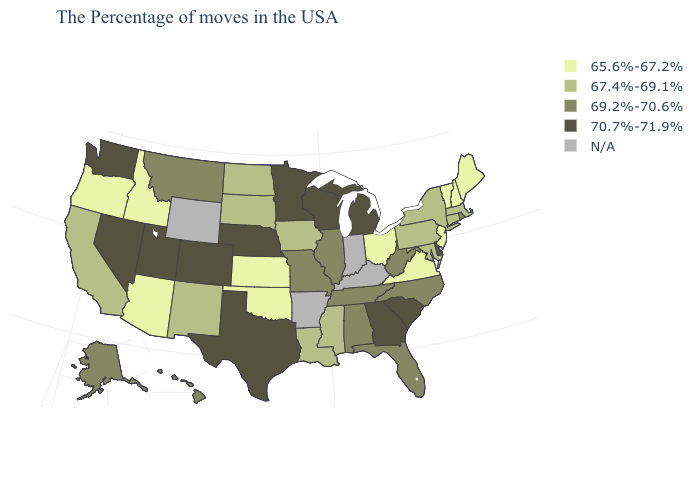What is the value of Arizona?
Short answer required. 65.6%-67.2%. What is the value of Kentucky?
Quick response, please. N/A. What is the lowest value in the MidWest?
Give a very brief answer. 65.6%-67.2%. Does Missouri have the lowest value in the MidWest?
Answer briefly. No. What is the value of Idaho?
Answer briefly. 65.6%-67.2%. What is the value of Utah?
Keep it brief. 70.7%-71.9%. Which states hav the highest value in the MidWest?
Keep it brief. Michigan, Wisconsin, Minnesota, Nebraska. What is the value of Nebraska?
Quick response, please. 70.7%-71.9%. Name the states that have a value in the range 67.4%-69.1%?
Concise answer only. Massachusetts, Connecticut, New York, Maryland, Pennsylvania, Mississippi, Louisiana, Iowa, South Dakota, North Dakota, New Mexico, California. Name the states that have a value in the range 69.2%-70.6%?
Give a very brief answer. Rhode Island, North Carolina, West Virginia, Florida, Alabama, Tennessee, Illinois, Missouri, Montana, Alaska, Hawaii. Which states have the lowest value in the USA?
Write a very short answer. Maine, New Hampshire, Vermont, New Jersey, Virginia, Ohio, Kansas, Oklahoma, Arizona, Idaho, Oregon. What is the value of Mississippi?
Short answer required. 67.4%-69.1%. 